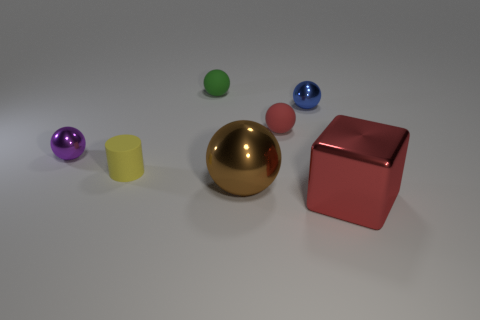Subtract 1 spheres. How many spheres are left? 4 Subtract all big balls. How many balls are left? 4 Subtract all blue spheres. How many spheres are left? 4 Subtract all cyan spheres. Subtract all brown cubes. How many spheres are left? 5 Add 1 tiny brown matte spheres. How many objects exist? 8 Subtract all cylinders. How many objects are left? 6 Subtract all small spheres. Subtract all big brown shiny balls. How many objects are left? 2 Add 3 red matte balls. How many red matte balls are left? 4 Add 2 green matte things. How many green matte things exist? 3 Subtract 1 yellow cylinders. How many objects are left? 6 